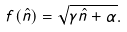Convert formula to latex. <formula><loc_0><loc_0><loc_500><loc_500>f ( \hat { n } ) = \sqrt { \gamma \hat { n } + \alpha } .</formula> 